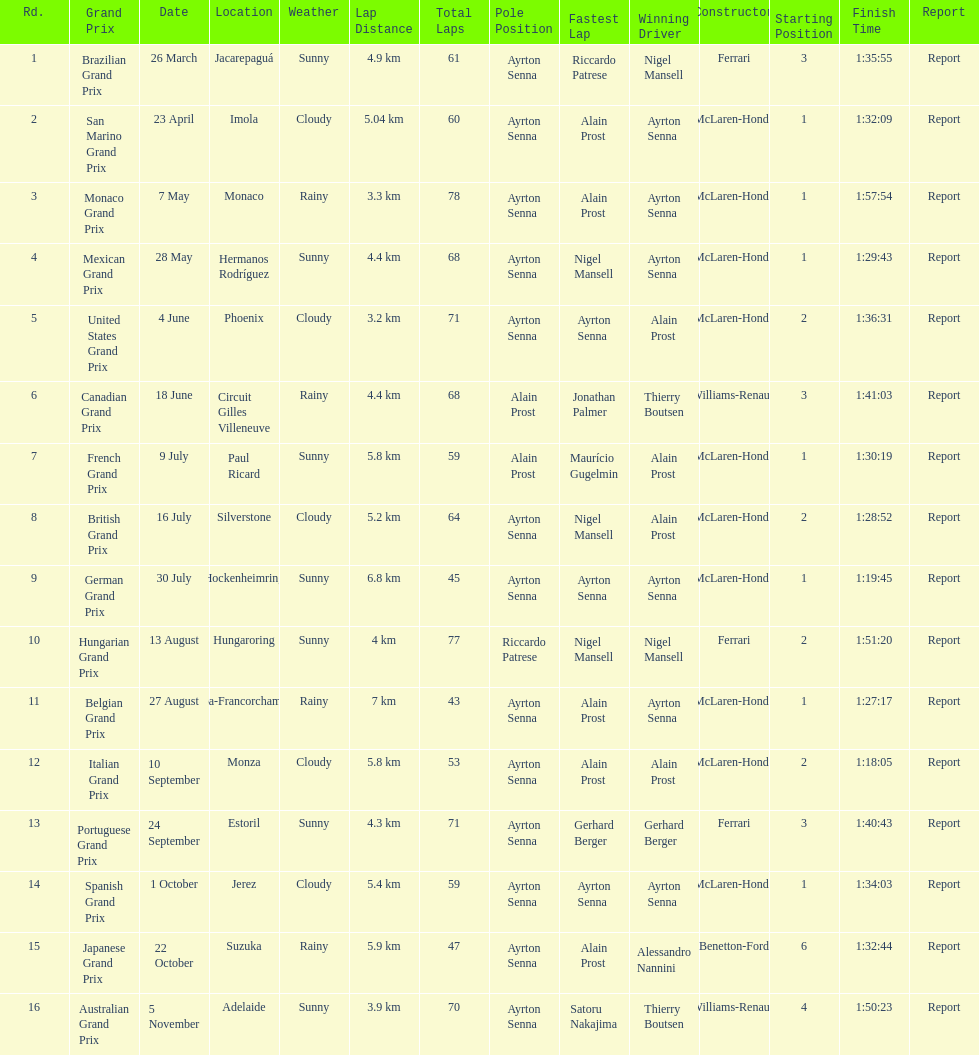Prost won the drivers title, who was his teammate? Ayrton Senna. 